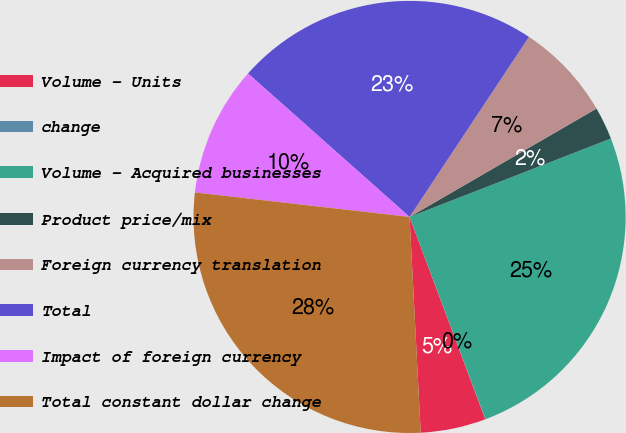<chart> <loc_0><loc_0><loc_500><loc_500><pie_chart><fcel>Volume - Units<fcel>change<fcel>Volume - Acquired businesses<fcel>Product price/mix<fcel>Foreign currency translation<fcel>Total<fcel>Impact of foreign currency<fcel>Total constant dollar change<nl><fcel>4.88%<fcel>0.02%<fcel>25.19%<fcel>2.45%<fcel>7.32%<fcel>22.76%<fcel>9.75%<fcel>27.63%<nl></chart> 